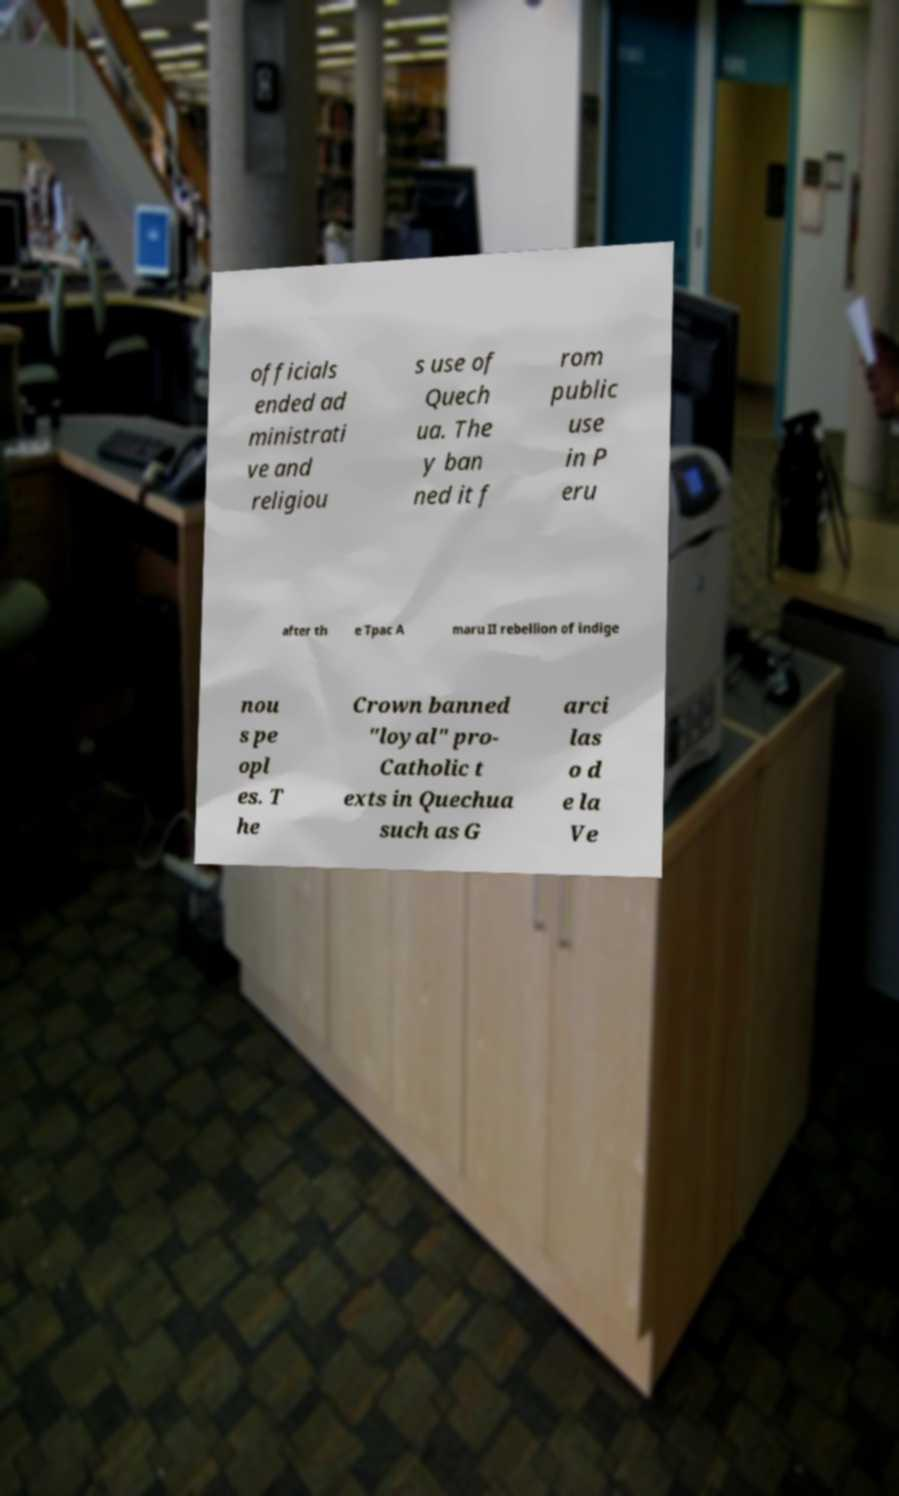Please read and relay the text visible in this image. What does it say? officials ended ad ministrati ve and religiou s use of Quech ua. The y ban ned it f rom public use in P eru after th e Tpac A maru II rebellion of indige nou s pe opl es. T he Crown banned "loyal" pro- Catholic t exts in Quechua such as G arci las o d e la Ve 